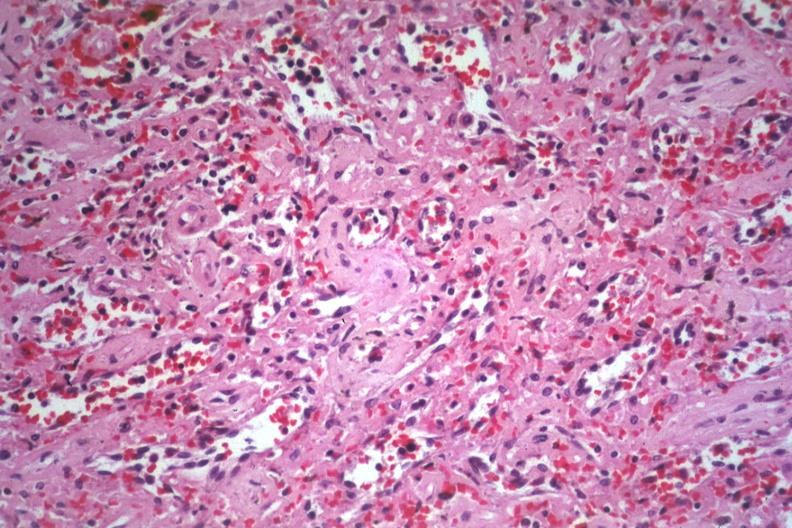s amyloidosis present?
Answer the question using a single word or phrase. Yes 